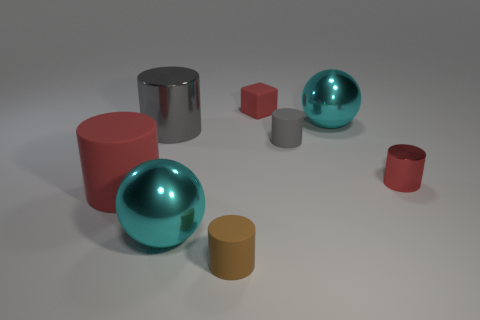There is a shiny sphere that is right of the sphere that is in front of the big thing right of the small gray cylinder; what size is it?
Give a very brief answer. Large. What number of objects are either gray metallic cylinders on the left side of the cube or gray cylinders to the left of the small gray matte object?
Ensure brevity in your answer.  1. What shape is the gray metallic object?
Provide a succinct answer. Cylinder. The brown object that is the same shape as the large gray metallic object is what size?
Ensure brevity in your answer.  Small. What material is the cyan thing that is behind the metallic thing left of the big cyan metal sphere that is in front of the big matte thing made of?
Ensure brevity in your answer.  Metal. Are there any large cyan shiny spheres?
Keep it short and to the point. Yes. There is a small metallic object; is it the same color as the matte object behind the small gray matte cylinder?
Ensure brevity in your answer.  Yes. What is the color of the large matte thing?
Make the answer very short. Red. Is there anything else that is the same shape as the gray metal object?
Offer a very short reply. Yes. There is another small metallic thing that is the same shape as the small gray object; what color is it?
Provide a short and direct response. Red. 